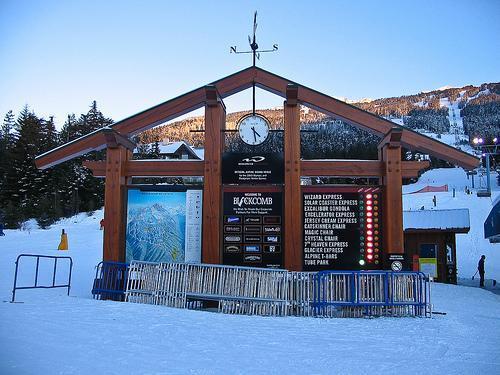How many clocks are shown?
Give a very brief answer. 1. 